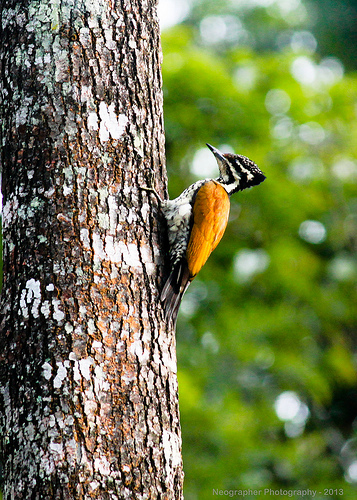Can you describe the bird seen in the image? This bird, perched on the tree trunk, exhibits a striking pattern of black and white on its head and a rich brown body, likely a species adapted to woodland habitats. Its sharp beak and robust body suggest it might feed on insects and small vertebrates found in tree barks. 